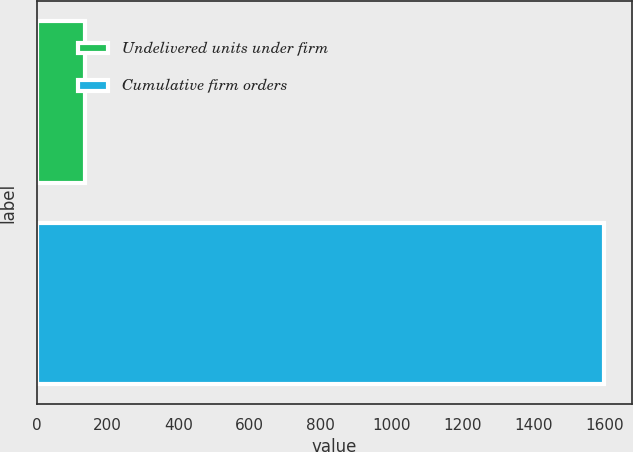<chart> <loc_0><loc_0><loc_500><loc_500><bar_chart><fcel>Undelivered units under firm<fcel>Cumulative firm orders<nl><fcel>136<fcel>1596<nl></chart> 